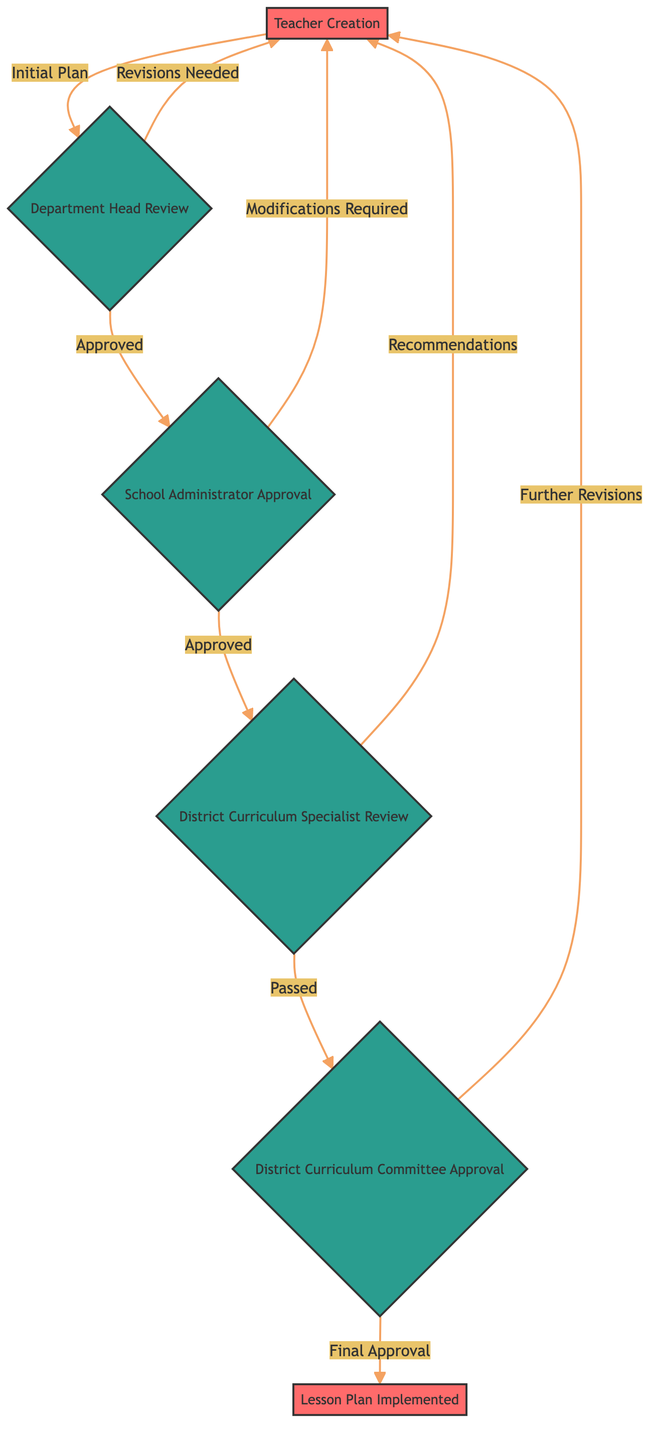What is the first step in the lesson plan approval process? The first step in the process is "Teacher Creation," where the initial lesson plan is crafted by the teacher.
Answer: Teacher Creation How many approval stages are there after the "Department Head Review"? After the "Department Head Review," there are three further stages: "School Administrator Approval," "District Curriculum Specialist Review," and "District Curriculum Committee Approval."
Answer: Three What happens if the lesson plan is approved by the School Administrator? If the lesson plan is approved by the School Administrator, it proceeds to the "District Curriculum Specialist Review" stage for further evaluation.
Answer: District Curriculum Specialist Review What is one of the key steps in the "Department Head Review"? One key step in the "Department Head Review" is to check alignment with the curriculum to ensure it meets department standards.
Answer: Check alignment with curriculum How does the district curriculum committee conclude the approval process? The district curriculum committee concludes the approval process with a "Final Approval," which allows the lesson plan to be implemented.
Answer: Final Approval What can happen if the district curriculum specialist provides recommendations? If the district curriculum specialist provides recommendations, the lesson plan may be sent back to the teacher for further revisions based on those recommendations.
Answer: Further Revisions Which node leads to the final implementation of the lesson plan? The node that leads to the final implementation is the "District Curriculum Committee Approval," which gives the final approval for the lesson plan to be implemented.
Answer: District Curriculum Committee Approval How many total feedback loops exist in the diagram? The diagram indicates three feedback loops where the lesson plan can be sent back to the teacher at different stages: after the "Department Head Review," after "School Administrator Approval," and after "District Curriculum Specialist Review."
Answer: Three What is the main purpose of the "District Curriculum Specialist Review"? The main purpose of the "District Curriculum Specialist Review" is to evaluate the lesson plan against district standards and ensure compliance with state educational guidelines.
Answer: Evaluate the lesson plan against district standards 